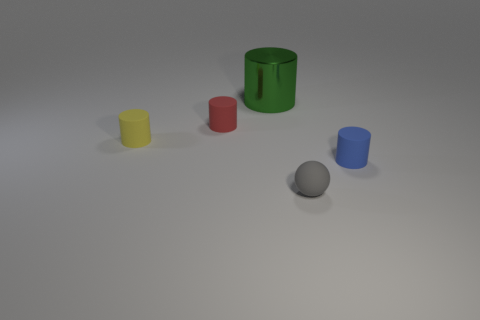Subtract all big cylinders. How many cylinders are left? 3 Subtract all green cylinders. How many cylinders are left? 3 Add 2 large red matte blocks. How many objects exist? 7 Subtract all cylinders. How many objects are left? 1 Subtract 3 cylinders. How many cylinders are left? 1 Subtract all blue cubes. How many red cylinders are left? 1 Add 3 small matte cylinders. How many small matte cylinders are left? 6 Add 5 small cyan shiny spheres. How many small cyan shiny spheres exist? 5 Subtract 0 purple cylinders. How many objects are left? 5 Subtract all green balls. Subtract all yellow cubes. How many balls are left? 1 